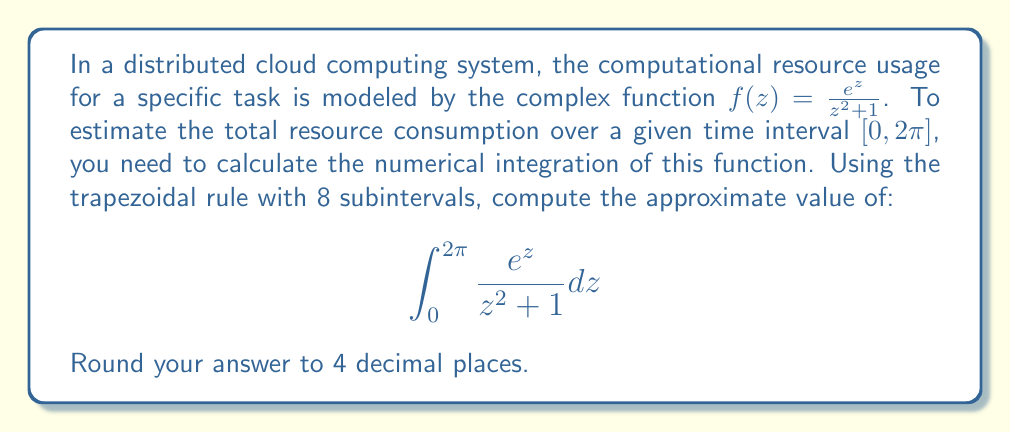Could you help me with this problem? To solve this problem using the trapezoidal rule with 8 subintervals, we'll follow these steps:

1) The trapezoidal rule formula for n subintervals is:

   $$\int_a^b f(x)dx \approx \frac{h}{2}[f(x_0) + 2f(x_1) + 2f(x_2) + ... + 2f(x_{n-1}) + f(x_n)]$$

   where $h = \frac{b-a}{n}$ and $x_i = a + ih$ for $i = 0, 1, ..., n$

2) In our case, $a = 0$, $b = 2\pi$, $n = 8$, and $f(z) = \frac{e^z}{z^2 + 1}$

3) Calculate $h$:
   $h = \frac{2\pi - 0}{8} = \frac{\pi}{4}$

4) Calculate the points $z_i$:
   $z_0 = 0$
   $z_1 = \frac{\pi}{4}$
   $z_2 = \frac{\pi}{2}$
   $z_3 = \frac{3\pi}{4}$
   $z_4 = \pi$
   $z_5 = \frac{5\pi}{4}$
   $z_6 = \frac{3\pi}{2}$
   $z_7 = \frac{7\pi}{4}$
   $z_8 = 2\pi$

5) Calculate $f(z_i)$ for each point:
   $f(z_0) = \frac{e^0}{0^2 + 1} = 1$
   $f(z_1) = \frac{e^{\pi/4}}{(\pi/4)^2 + 1} \approx 1.6681$
   $f(z_2) = \frac{e^{\pi/2}}{(\pi/2)^2 + 1} \approx 1.3703$
   $f(z_3) = \frac{e^{3\pi/4}}{(3\pi/4)^2 + 1} \approx 1.3176$
   $f(z_4) = \frac{e^{\pi}}{\pi^2 + 1} \approx 0.8776$
   $f(z_5) = \frac{e^{5\pi/4}}{(5\pi/4)^2 + 1} \approx 0.5355$
   $f(z_6) = \frac{e^{3\pi/2}}{(3\pi/2)^2 + 1} \approx 0.3215$
   $f(z_7) = \frac{e^{7\pi/4}}{(7\pi/4)^2 + 1} \approx 0.1915$
   $f(z_8) = \frac{e^{2\pi}}{(2\pi)^2 + 1} \approx 0.1136$

6) Apply the trapezoidal rule:
   $$\int_0^{2\pi} \frac{e^z}{z^2 + 1} dz \approx \frac{\pi}{8}[1 + 2(1.6681 + 1.3703 + 1.3176 + 0.8776 + 0.5355 + 0.3215 + 0.1915) + 0.1136]$$

7) Simplify:
   $$\approx \frac{\pi}{8}[1 + 2(6.2821) + 0.1136] = \frac{\pi}{8}[13.6778] = 1.6897\pi \approx 5.3057$$

8) Round to 4 decimal places: 5.3057
Answer: 5.3057 